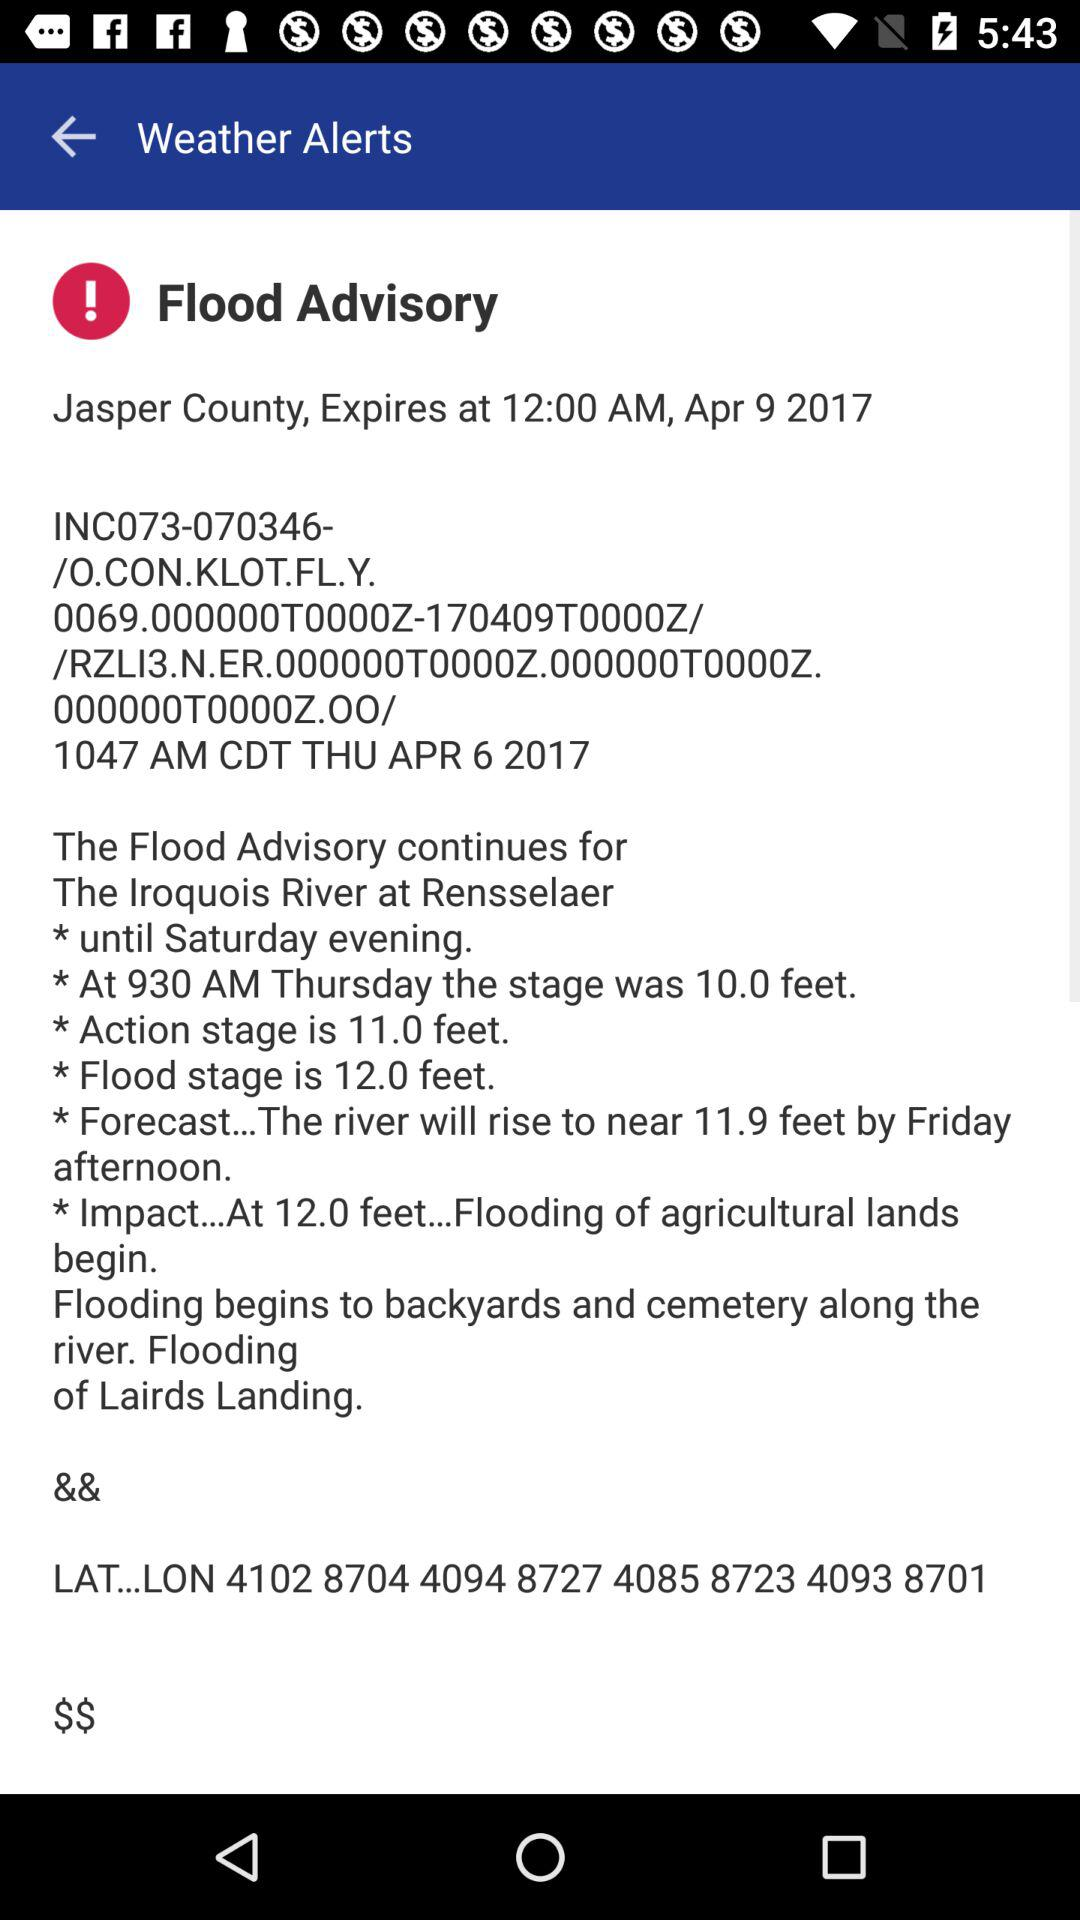What's the flood advisory alert location? The flood advisory alert location is Jasper County. 